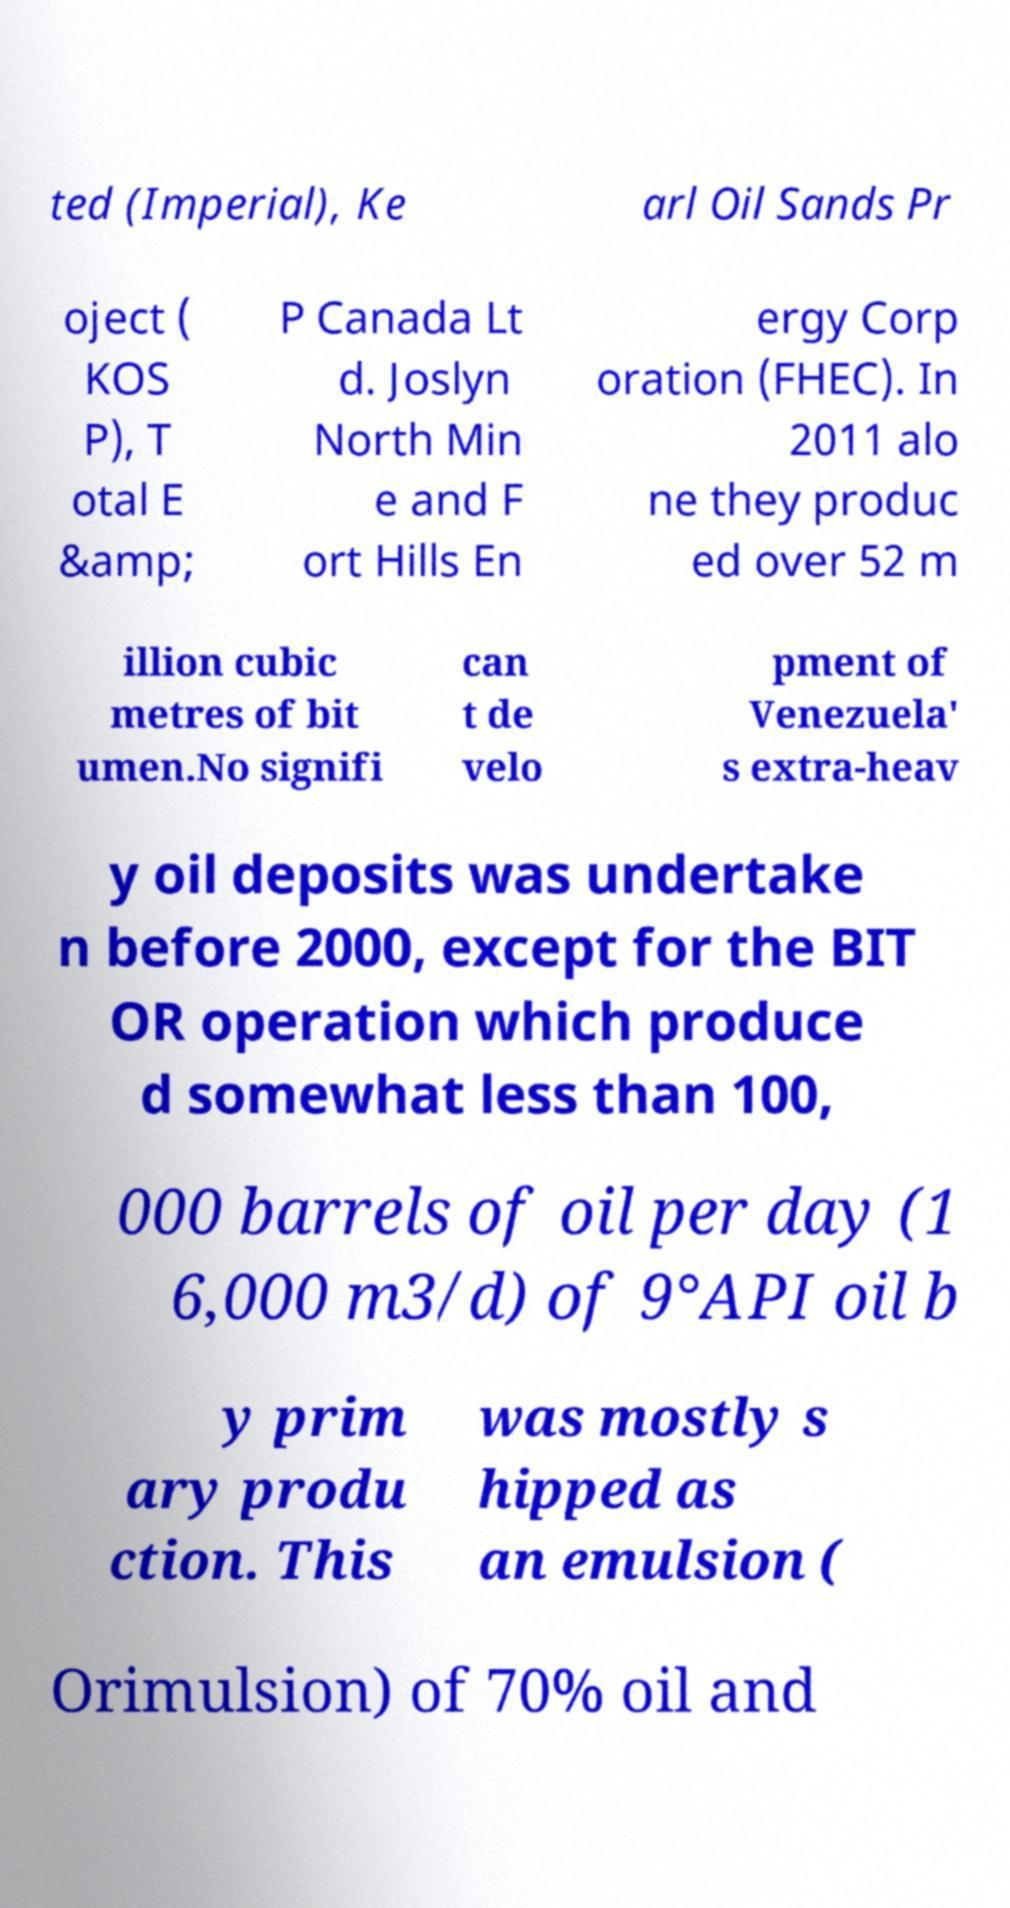For documentation purposes, I need the text within this image transcribed. Could you provide that? ted (Imperial), Ke arl Oil Sands Pr oject ( KOS P), T otal E &amp; P Canada Lt d. Joslyn North Min e and F ort Hills En ergy Corp oration (FHEC). In 2011 alo ne they produc ed over 52 m illion cubic metres of bit umen.No signifi can t de velo pment of Venezuela' s extra-heav y oil deposits was undertake n before 2000, except for the BIT OR operation which produce d somewhat less than 100, 000 barrels of oil per day (1 6,000 m3/d) of 9°API oil b y prim ary produ ction. This was mostly s hipped as an emulsion ( Orimulsion) of 70% oil and 